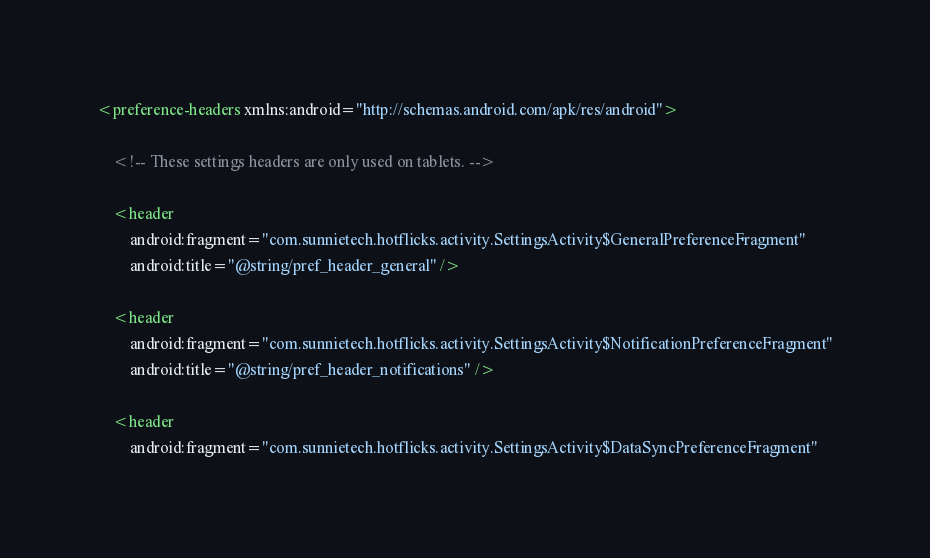Convert code to text. <code><loc_0><loc_0><loc_500><loc_500><_XML_><preference-headers xmlns:android="http://schemas.android.com/apk/res/android">

    <!-- These settings headers are only used on tablets. -->

    <header
        android:fragment="com.sunnietech.hotflicks.activity.SettingsActivity$GeneralPreferenceFragment"
        android:title="@string/pref_header_general" />

    <header
        android:fragment="com.sunnietech.hotflicks.activity.SettingsActivity$NotificationPreferenceFragment"
        android:title="@string/pref_header_notifications" />

    <header
        android:fragment="com.sunnietech.hotflicks.activity.SettingsActivity$DataSyncPreferenceFragment"</code> 